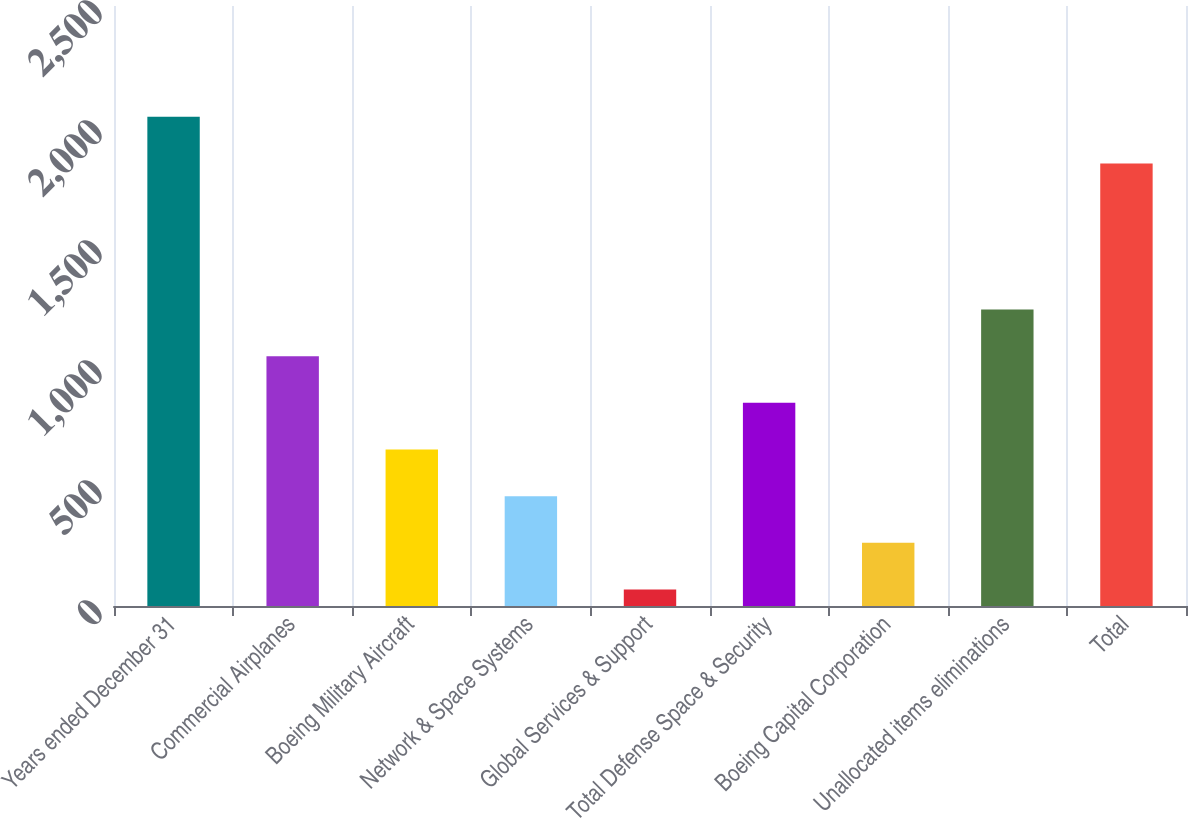Convert chart to OTSL. <chart><loc_0><loc_0><loc_500><loc_500><bar_chart><fcel>Years ended December 31<fcel>Commercial Airplanes<fcel>Boeing Military Aircraft<fcel>Network & Space Systems<fcel>Global Services & Support<fcel>Total Defense Space & Security<fcel>Boeing Capital Corporation<fcel>Unallocated items eliminations<fcel>Total<nl><fcel>2038.4<fcel>1041<fcel>652.2<fcel>457.8<fcel>69<fcel>846.6<fcel>263.4<fcel>1235.4<fcel>1844<nl></chart> 